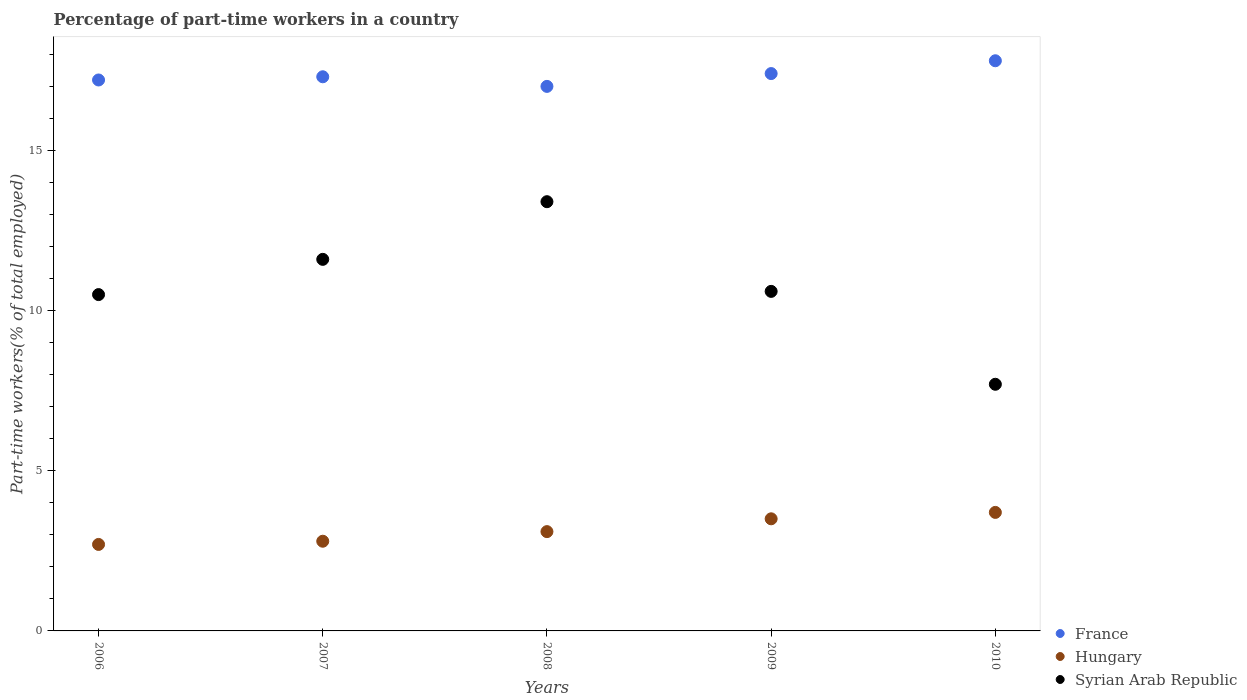How many different coloured dotlines are there?
Keep it short and to the point. 3. Is the number of dotlines equal to the number of legend labels?
Your answer should be compact. Yes. What is the percentage of part-time workers in Hungary in 2009?
Provide a succinct answer. 3.5. Across all years, what is the maximum percentage of part-time workers in France?
Your answer should be compact. 17.8. Across all years, what is the minimum percentage of part-time workers in Hungary?
Offer a very short reply. 2.7. In which year was the percentage of part-time workers in Syrian Arab Republic maximum?
Your answer should be compact. 2008. In which year was the percentage of part-time workers in France minimum?
Ensure brevity in your answer.  2008. What is the total percentage of part-time workers in Syrian Arab Republic in the graph?
Ensure brevity in your answer.  53.8. What is the difference between the percentage of part-time workers in Hungary in 2008 and that in 2010?
Provide a short and direct response. -0.6. What is the difference between the percentage of part-time workers in Hungary in 2006 and the percentage of part-time workers in France in 2008?
Your response must be concise. -14.3. What is the average percentage of part-time workers in Hungary per year?
Your answer should be very brief. 3.16. In the year 2007, what is the difference between the percentage of part-time workers in Hungary and percentage of part-time workers in Syrian Arab Republic?
Your answer should be compact. -8.8. What is the ratio of the percentage of part-time workers in France in 2008 to that in 2010?
Ensure brevity in your answer.  0.96. What is the difference between the highest and the second highest percentage of part-time workers in Hungary?
Make the answer very short. 0.2. What is the difference between the highest and the lowest percentage of part-time workers in France?
Offer a terse response. 0.8. In how many years, is the percentage of part-time workers in Hungary greater than the average percentage of part-time workers in Hungary taken over all years?
Make the answer very short. 2. Is the sum of the percentage of part-time workers in France in 2007 and 2009 greater than the maximum percentage of part-time workers in Hungary across all years?
Provide a succinct answer. Yes. Does the percentage of part-time workers in Hungary monotonically increase over the years?
Provide a short and direct response. Yes. Is the percentage of part-time workers in Syrian Arab Republic strictly greater than the percentage of part-time workers in France over the years?
Your response must be concise. No. Is the percentage of part-time workers in France strictly less than the percentage of part-time workers in Syrian Arab Republic over the years?
Your response must be concise. No. How many dotlines are there?
Provide a short and direct response. 3. Does the graph contain any zero values?
Give a very brief answer. No. How many legend labels are there?
Your answer should be compact. 3. How are the legend labels stacked?
Offer a terse response. Vertical. What is the title of the graph?
Provide a short and direct response. Percentage of part-time workers in a country. Does "Romania" appear as one of the legend labels in the graph?
Keep it short and to the point. No. What is the label or title of the X-axis?
Offer a terse response. Years. What is the label or title of the Y-axis?
Give a very brief answer. Part-time workers(% of total employed). What is the Part-time workers(% of total employed) of France in 2006?
Your answer should be very brief. 17.2. What is the Part-time workers(% of total employed) in Hungary in 2006?
Your answer should be compact. 2.7. What is the Part-time workers(% of total employed) in Syrian Arab Republic in 2006?
Your answer should be very brief. 10.5. What is the Part-time workers(% of total employed) of France in 2007?
Give a very brief answer. 17.3. What is the Part-time workers(% of total employed) in Hungary in 2007?
Give a very brief answer. 2.8. What is the Part-time workers(% of total employed) of Syrian Arab Republic in 2007?
Provide a succinct answer. 11.6. What is the Part-time workers(% of total employed) in France in 2008?
Provide a succinct answer. 17. What is the Part-time workers(% of total employed) of Hungary in 2008?
Keep it short and to the point. 3.1. What is the Part-time workers(% of total employed) of Syrian Arab Republic in 2008?
Provide a short and direct response. 13.4. What is the Part-time workers(% of total employed) of France in 2009?
Provide a short and direct response. 17.4. What is the Part-time workers(% of total employed) of Hungary in 2009?
Your response must be concise. 3.5. What is the Part-time workers(% of total employed) of Syrian Arab Republic in 2009?
Give a very brief answer. 10.6. What is the Part-time workers(% of total employed) in France in 2010?
Provide a short and direct response. 17.8. What is the Part-time workers(% of total employed) of Hungary in 2010?
Provide a succinct answer. 3.7. What is the Part-time workers(% of total employed) of Syrian Arab Republic in 2010?
Give a very brief answer. 7.7. Across all years, what is the maximum Part-time workers(% of total employed) of France?
Provide a succinct answer. 17.8. Across all years, what is the maximum Part-time workers(% of total employed) of Hungary?
Keep it short and to the point. 3.7. Across all years, what is the maximum Part-time workers(% of total employed) in Syrian Arab Republic?
Offer a very short reply. 13.4. Across all years, what is the minimum Part-time workers(% of total employed) in France?
Provide a short and direct response. 17. Across all years, what is the minimum Part-time workers(% of total employed) in Hungary?
Your answer should be very brief. 2.7. Across all years, what is the minimum Part-time workers(% of total employed) of Syrian Arab Republic?
Provide a succinct answer. 7.7. What is the total Part-time workers(% of total employed) of France in the graph?
Make the answer very short. 86.7. What is the total Part-time workers(% of total employed) of Hungary in the graph?
Offer a terse response. 15.8. What is the total Part-time workers(% of total employed) of Syrian Arab Republic in the graph?
Make the answer very short. 53.8. What is the difference between the Part-time workers(% of total employed) of France in 2006 and that in 2007?
Your answer should be very brief. -0.1. What is the difference between the Part-time workers(% of total employed) of Hungary in 2006 and that in 2007?
Give a very brief answer. -0.1. What is the difference between the Part-time workers(% of total employed) of Syrian Arab Republic in 2006 and that in 2007?
Keep it short and to the point. -1.1. What is the difference between the Part-time workers(% of total employed) in Syrian Arab Republic in 2006 and that in 2008?
Provide a succinct answer. -2.9. What is the difference between the Part-time workers(% of total employed) of Hungary in 2006 and that in 2009?
Make the answer very short. -0.8. What is the difference between the Part-time workers(% of total employed) in France in 2006 and that in 2010?
Provide a succinct answer. -0.6. What is the difference between the Part-time workers(% of total employed) in Hungary in 2006 and that in 2010?
Offer a terse response. -1. What is the difference between the Part-time workers(% of total employed) in Syrian Arab Republic in 2006 and that in 2010?
Ensure brevity in your answer.  2.8. What is the difference between the Part-time workers(% of total employed) in France in 2007 and that in 2008?
Offer a very short reply. 0.3. What is the difference between the Part-time workers(% of total employed) in Hungary in 2007 and that in 2008?
Your answer should be compact. -0.3. What is the difference between the Part-time workers(% of total employed) of France in 2007 and that in 2009?
Your answer should be compact. -0.1. What is the difference between the Part-time workers(% of total employed) of Hungary in 2007 and that in 2009?
Provide a succinct answer. -0.7. What is the difference between the Part-time workers(% of total employed) of Hungary in 2007 and that in 2010?
Make the answer very short. -0.9. What is the difference between the Part-time workers(% of total employed) in France in 2008 and that in 2009?
Provide a short and direct response. -0.4. What is the difference between the Part-time workers(% of total employed) in Syrian Arab Republic in 2008 and that in 2009?
Make the answer very short. 2.8. What is the difference between the Part-time workers(% of total employed) in France in 2008 and that in 2010?
Make the answer very short. -0.8. What is the difference between the Part-time workers(% of total employed) of Hungary in 2009 and that in 2010?
Your response must be concise. -0.2. What is the difference between the Part-time workers(% of total employed) in Syrian Arab Republic in 2009 and that in 2010?
Provide a succinct answer. 2.9. What is the difference between the Part-time workers(% of total employed) of Hungary in 2006 and the Part-time workers(% of total employed) of Syrian Arab Republic in 2007?
Offer a very short reply. -8.9. What is the difference between the Part-time workers(% of total employed) of France in 2006 and the Part-time workers(% of total employed) of Syrian Arab Republic in 2008?
Ensure brevity in your answer.  3.8. What is the difference between the Part-time workers(% of total employed) in Hungary in 2006 and the Part-time workers(% of total employed) in Syrian Arab Republic in 2009?
Offer a terse response. -7.9. What is the difference between the Part-time workers(% of total employed) in France in 2006 and the Part-time workers(% of total employed) in Hungary in 2010?
Provide a succinct answer. 13.5. What is the difference between the Part-time workers(% of total employed) in France in 2006 and the Part-time workers(% of total employed) in Syrian Arab Republic in 2010?
Provide a succinct answer. 9.5. What is the difference between the Part-time workers(% of total employed) of France in 2007 and the Part-time workers(% of total employed) of Syrian Arab Republic in 2008?
Your response must be concise. 3.9. What is the difference between the Part-time workers(% of total employed) of Hungary in 2007 and the Part-time workers(% of total employed) of Syrian Arab Republic in 2008?
Give a very brief answer. -10.6. What is the difference between the Part-time workers(% of total employed) in France in 2007 and the Part-time workers(% of total employed) in Hungary in 2009?
Your answer should be very brief. 13.8. What is the difference between the Part-time workers(% of total employed) in France in 2007 and the Part-time workers(% of total employed) in Hungary in 2010?
Offer a terse response. 13.6. What is the difference between the Part-time workers(% of total employed) in Hungary in 2007 and the Part-time workers(% of total employed) in Syrian Arab Republic in 2010?
Your answer should be very brief. -4.9. What is the difference between the Part-time workers(% of total employed) of Hungary in 2008 and the Part-time workers(% of total employed) of Syrian Arab Republic in 2009?
Provide a succinct answer. -7.5. What is the difference between the Part-time workers(% of total employed) of France in 2008 and the Part-time workers(% of total employed) of Hungary in 2010?
Ensure brevity in your answer.  13.3. What is the difference between the Part-time workers(% of total employed) of France in 2008 and the Part-time workers(% of total employed) of Syrian Arab Republic in 2010?
Ensure brevity in your answer.  9.3. What is the difference between the Part-time workers(% of total employed) of Hungary in 2008 and the Part-time workers(% of total employed) of Syrian Arab Republic in 2010?
Your answer should be compact. -4.6. What is the difference between the Part-time workers(% of total employed) of France in 2009 and the Part-time workers(% of total employed) of Hungary in 2010?
Your response must be concise. 13.7. What is the difference between the Part-time workers(% of total employed) of France in 2009 and the Part-time workers(% of total employed) of Syrian Arab Republic in 2010?
Offer a very short reply. 9.7. What is the difference between the Part-time workers(% of total employed) of Hungary in 2009 and the Part-time workers(% of total employed) of Syrian Arab Republic in 2010?
Make the answer very short. -4.2. What is the average Part-time workers(% of total employed) in France per year?
Provide a short and direct response. 17.34. What is the average Part-time workers(% of total employed) in Hungary per year?
Offer a terse response. 3.16. What is the average Part-time workers(% of total employed) of Syrian Arab Republic per year?
Give a very brief answer. 10.76. In the year 2006, what is the difference between the Part-time workers(% of total employed) of France and Part-time workers(% of total employed) of Syrian Arab Republic?
Provide a succinct answer. 6.7. In the year 2006, what is the difference between the Part-time workers(% of total employed) in Hungary and Part-time workers(% of total employed) in Syrian Arab Republic?
Offer a very short reply. -7.8. In the year 2008, what is the difference between the Part-time workers(% of total employed) of France and Part-time workers(% of total employed) of Hungary?
Give a very brief answer. 13.9. In the year 2008, what is the difference between the Part-time workers(% of total employed) of France and Part-time workers(% of total employed) of Syrian Arab Republic?
Your answer should be compact. 3.6. In the year 2008, what is the difference between the Part-time workers(% of total employed) of Hungary and Part-time workers(% of total employed) of Syrian Arab Republic?
Your answer should be compact. -10.3. In the year 2009, what is the difference between the Part-time workers(% of total employed) in France and Part-time workers(% of total employed) in Hungary?
Ensure brevity in your answer.  13.9. In the year 2010, what is the difference between the Part-time workers(% of total employed) of France and Part-time workers(% of total employed) of Hungary?
Your response must be concise. 14.1. In the year 2010, what is the difference between the Part-time workers(% of total employed) of Hungary and Part-time workers(% of total employed) of Syrian Arab Republic?
Your answer should be very brief. -4. What is the ratio of the Part-time workers(% of total employed) in Hungary in 2006 to that in 2007?
Your response must be concise. 0.96. What is the ratio of the Part-time workers(% of total employed) of Syrian Arab Republic in 2006 to that in 2007?
Offer a very short reply. 0.91. What is the ratio of the Part-time workers(% of total employed) of France in 2006 to that in 2008?
Provide a succinct answer. 1.01. What is the ratio of the Part-time workers(% of total employed) in Hungary in 2006 to that in 2008?
Your response must be concise. 0.87. What is the ratio of the Part-time workers(% of total employed) of Syrian Arab Republic in 2006 to that in 2008?
Make the answer very short. 0.78. What is the ratio of the Part-time workers(% of total employed) of Hungary in 2006 to that in 2009?
Your answer should be very brief. 0.77. What is the ratio of the Part-time workers(% of total employed) of Syrian Arab Republic in 2006 to that in 2009?
Provide a succinct answer. 0.99. What is the ratio of the Part-time workers(% of total employed) of France in 2006 to that in 2010?
Offer a very short reply. 0.97. What is the ratio of the Part-time workers(% of total employed) in Hungary in 2006 to that in 2010?
Your answer should be compact. 0.73. What is the ratio of the Part-time workers(% of total employed) of Syrian Arab Republic in 2006 to that in 2010?
Your response must be concise. 1.36. What is the ratio of the Part-time workers(% of total employed) in France in 2007 to that in 2008?
Offer a very short reply. 1.02. What is the ratio of the Part-time workers(% of total employed) in Hungary in 2007 to that in 2008?
Keep it short and to the point. 0.9. What is the ratio of the Part-time workers(% of total employed) of Syrian Arab Republic in 2007 to that in 2008?
Keep it short and to the point. 0.87. What is the ratio of the Part-time workers(% of total employed) in France in 2007 to that in 2009?
Give a very brief answer. 0.99. What is the ratio of the Part-time workers(% of total employed) in Hungary in 2007 to that in 2009?
Give a very brief answer. 0.8. What is the ratio of the Part-time workers(% of total employed) in Syrian Arab Republic in 2007 to that in 2009?
Your answer should be very brief. 1.09. What is the ratio of the Part-time workers(% of total employed) of France in 2007 to that in 2010?
Offer a very short reply. 0.97. What is the ratio of the Part-time workers(% of total employed) in Hungary in 2007 to that in 2010?
Make the answer very short. 0.76. What is the ratio of the Part-time workers(% of total employed) of Syrian Arab Republic in 2007 to that in 2010?
Provide a short and direct response. 1.51. What is the ratio of the Part-time workers(% of total employed) of Hungary in 2008 to that in 2009?
Provide a succinct answer. 0.89. What is the ratio of the Part-time workers(% of total employed) of Syrian Arab Republic in 2008 to that in 2009?
Ensure brevity in your answer.  1.26. What is the ratio of the Part-time workers(% of total employed) in France in 2008 to that in 2010?
Offer a very short reply. 0.96. What is the ratio of the Part-time workers(% of total employed) in Hungary in 2008 to that in 2010?
Keep it short and to the point. 0.84. What is the ratio of the Part-time workers(% of total employed) of Syrian Arab Republic in 2008 to that in 2010?
Your answer should be compact. 1.74. What is the ratio of the Part-time workers(% of total employed) in France in 2009 to that in 2010?
Give a very brief answer. 0.98. What is the ratio of the Part-time workers(% of total employed) of Hungary in 2009 to that in 2010?
Give a very brief answer. 0.95. What is the ratio of the Part-time workers(% of total employed) of Syrian Arab Republic in 2009 to that in 2010?
Your response must be concise. 1.38. 